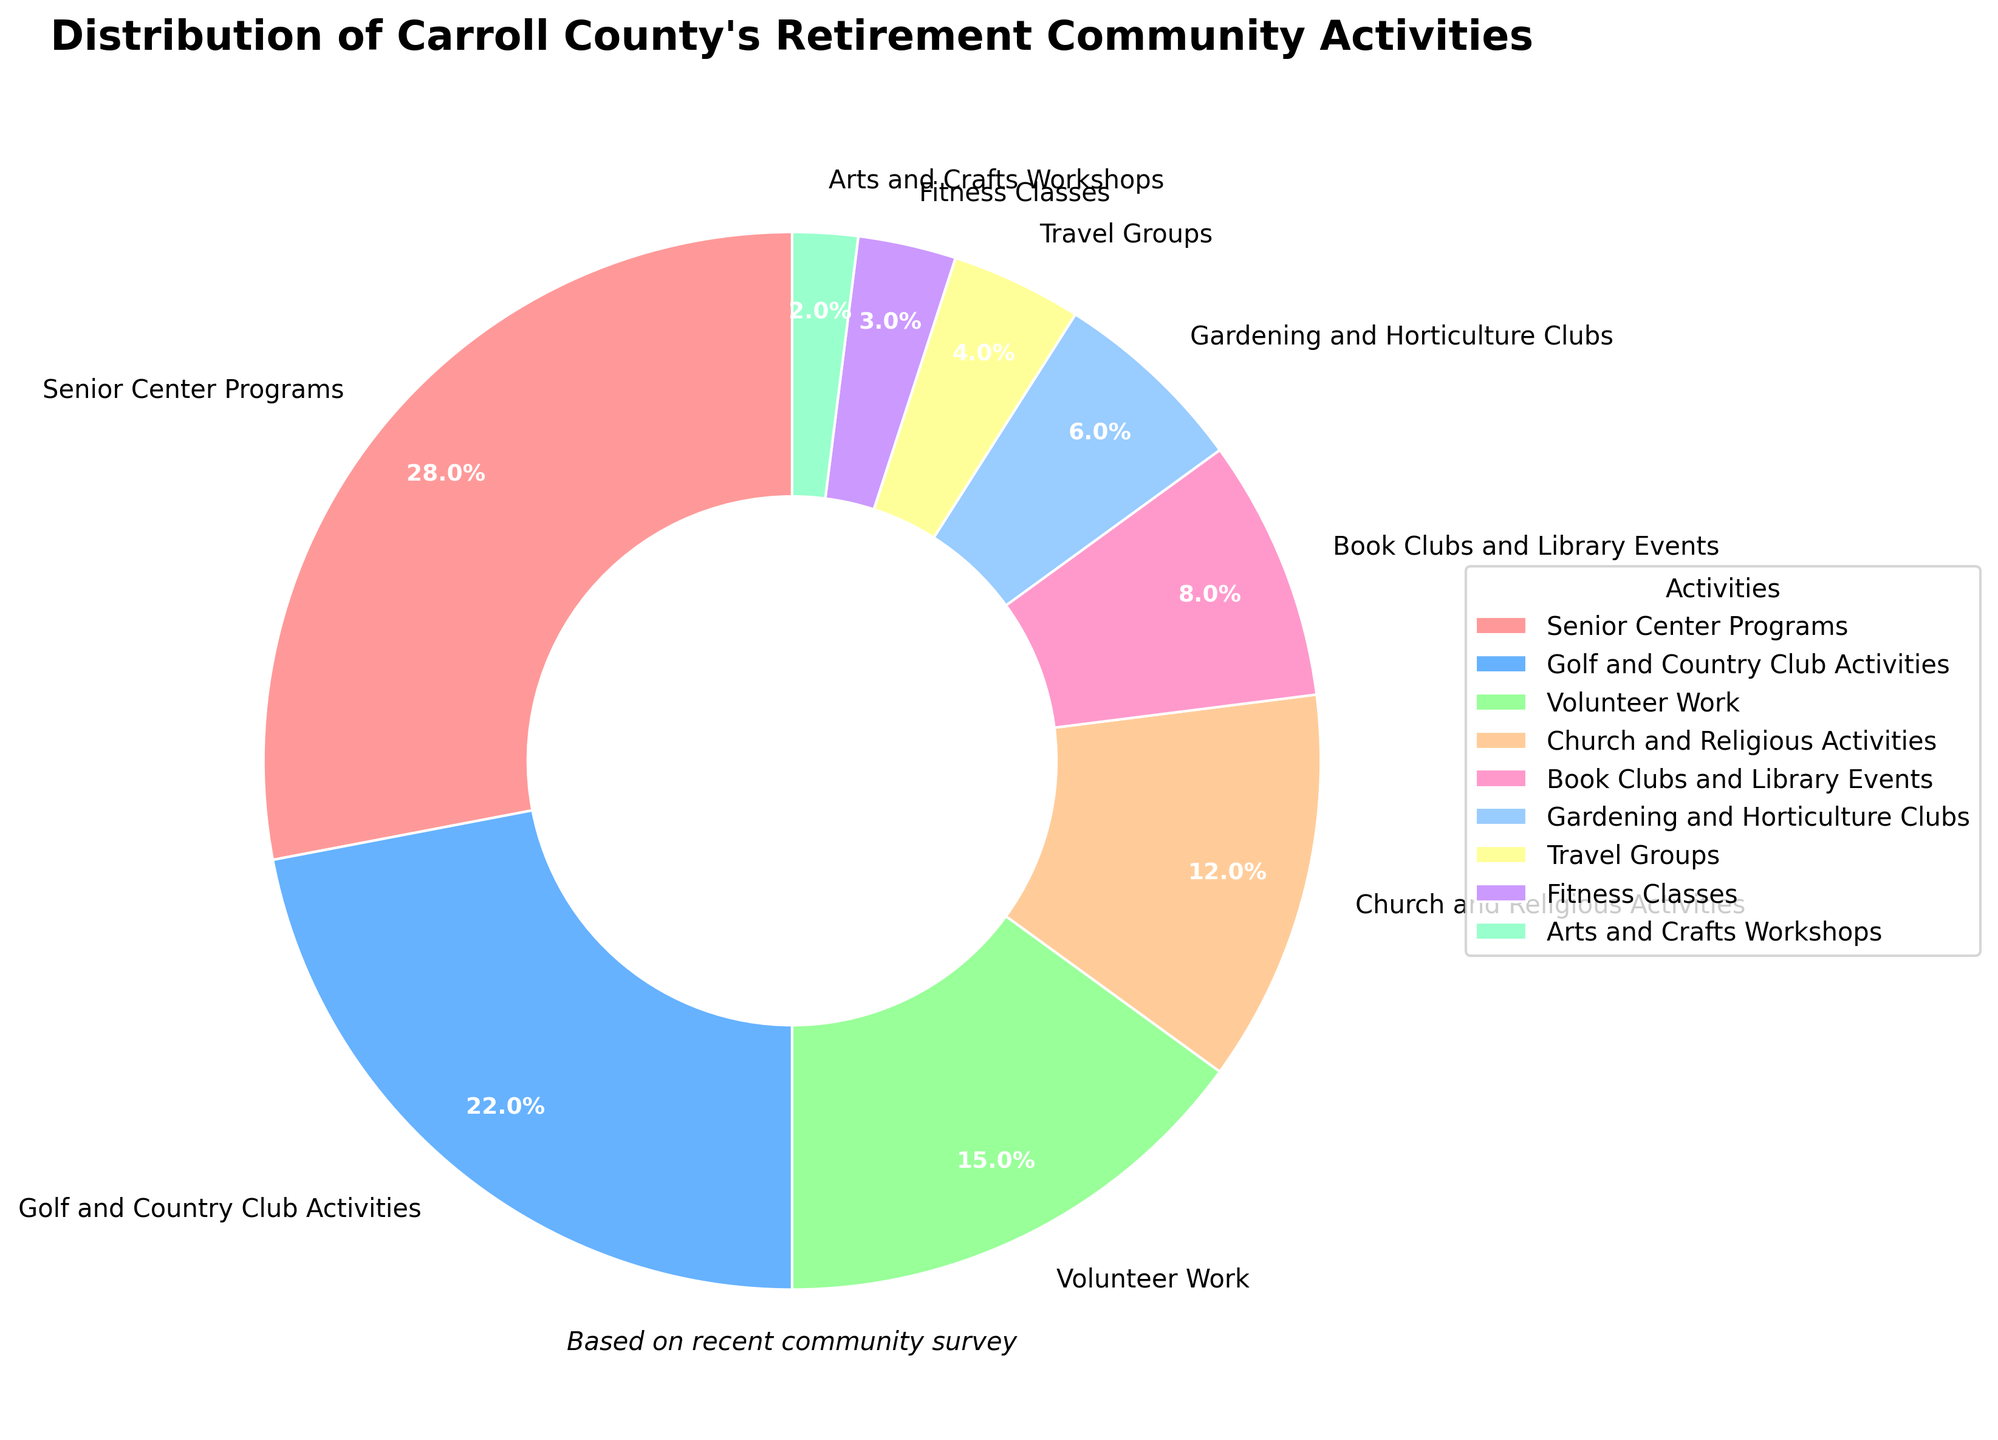What's the most popular activity among Carroll County's retirement community? The pie chart shows different activities with their respective percentages. The largest wedge corresponds to "Senior Center Programs" with 28%.
Answer: Senior Center Programs Which activity has the lowest participation? By looking at the smallest wedge in the pie chart, we see that "Arts and Crafts Workshops" has the smallest percentage at 2%.
Answer: Arts and Crafts Workshops What is the combined percentage of activities related to fitness, gardening, and travel? Sum the percentages of "Fitness Classes" (3%), "Gardening and Horticulture Clubs" (6%), and "Travel Groups" (4%): 3 + 6 + 4 = 13%.
Answer: 13% Are Golf and Country Club Activities more popular than Church and Religious Activities? Compare the percentages: "Golf and Country Club Activities" is 22% and "Church and Religious Activities" is 12%. Since 22% is greater than 12%, the former is more popular.
Answer: Yes What is the difference in participation between Senior Center Programs and Book Clubs and Library Events? Subtract the percentage of "Book Clubs and Library Events" (8%) from that of "Senior Center Programs" (28%): 28 - 8 = 20%.
Answer: 20% If the least popular activities (less than 5%) are grouped together, what total percentage do they represent? Identify activities with less than 5%: "Travel Groups" (4%), "Fitness Classes" (3%), "Arts and Crafts Workshops" (2%). Sum these: 4 + 3 + 2 = 9%.
Answer: 9% In the pie chart, which activity segment is displayed in blue, and what percentage does it represent? Identify the color wedge corresponding to blue from the pie chart. "Golf and Country Club Activities" is displayed in blue and it represents 22%.
Answer: Golf and Country Club Activities, 22% What is the ratio of participation in Volunteer Work compared to Church and Religious Activities? Divide the percentage of "Volunteer Work" (15%) by that of "Church and Religious Activities" (12%): 15 / 12 ≈ 1.25.
Answer: 1.25 What is the combined percentage of Book Clubs and Library Events, and Travel Groups? Sum the percentages of "Book Clubs and Library Events" (8%) and "Travel Groups" (4%): 8 + 4 = 12%.
Answer: 12% Which activity occupies a larger area on the pie chart: Gardening and Horticulture Clubs or Fitness Classes? Compare their percentages: "Gardening and Horticulture Clubs" has 6% while "Fitness Classes" has 3%. Since 6% is greater than 3%, Gardening and Horticulture Clubs occupy a larger area.
Answer: Gardening and Horticulture Clubs 